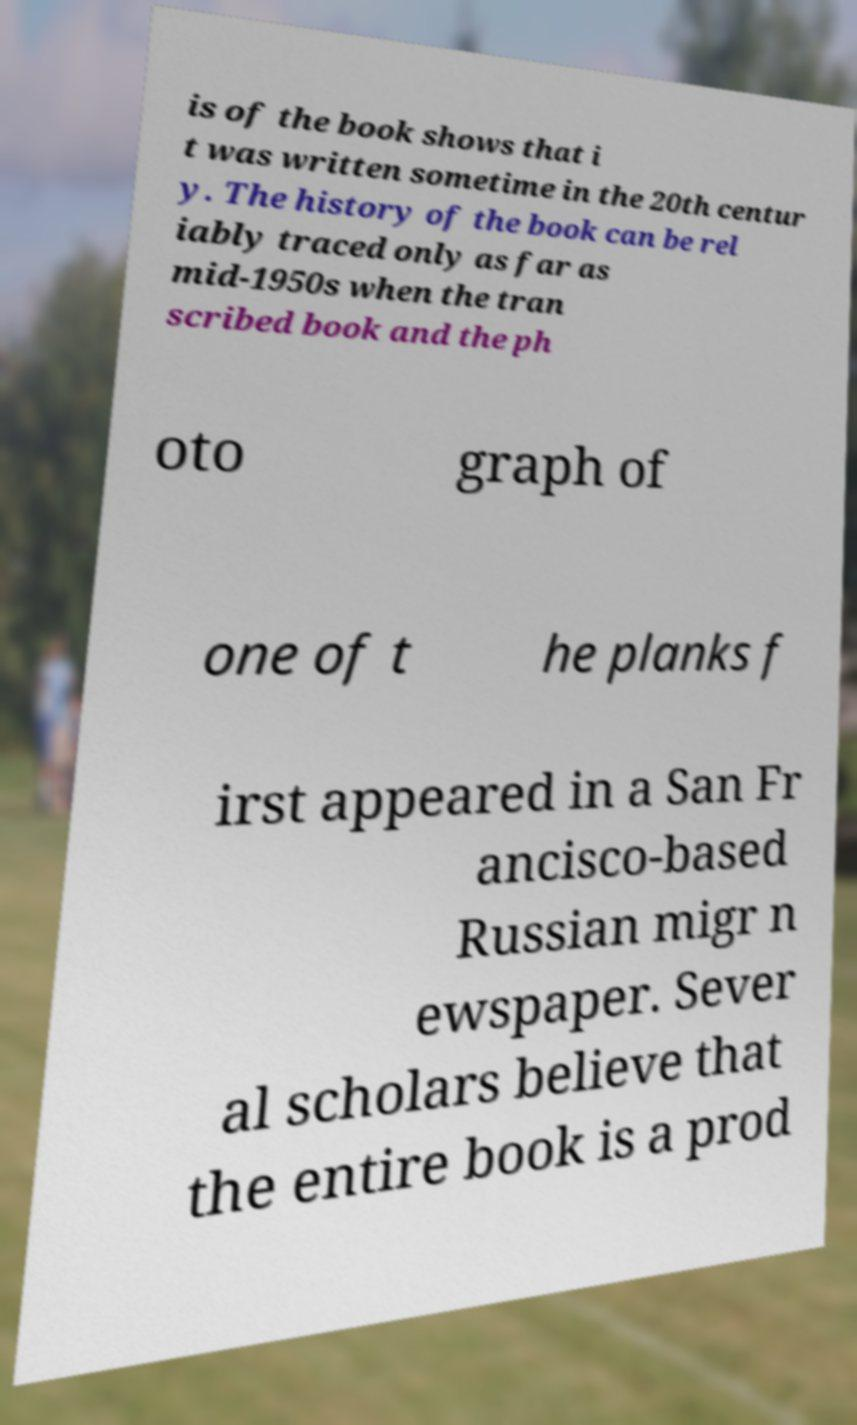Can you read and provide the text displayed in the image?This photo seems to have some interesting text. Can you extract and type it out for me? is of the book shows that i t was written sometime in the 20th centur y. The history of the book can be rel iably traced only as far as mid-1950s when the tran scribed book and the ph oto graph of one of t he planks f irst appeared in a San Fr ancisco-based Russian migr n ewspaper. Sever al scholars believe that the entire book is a prod 